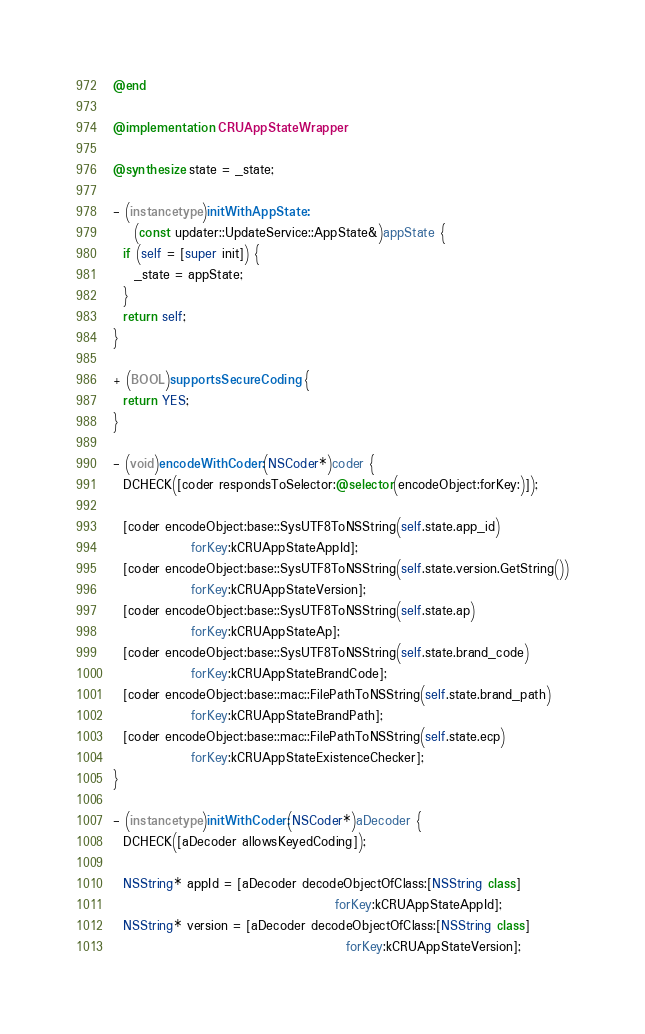<code> <loc_0><loc_0><loc_500><loc_500><_ObjectiveC_>
@end

@implementation CRUAppStateWrapper

@synthesize state = _state;

- (instancetype)initWithAppState:
    (const updater::UpdateService::AppState&)appState {
  if (self = [super init]) {
    _state = appState;
  }
  return self;
}

+ (BOOL)supportsSecureCoding {
  return YES;
}

- (void)encodeWithCoder:(NSCoder*)coder {
  DCHECK([coder respondsToSelector:@selector(encodeObject:forKey:)]);

  [coder encodeObject:base::SysUTF8ToNSString(self.state.app_id)
               forKey:kCRUAppStateAppId];
  [coder encodeObject:base::SysUTF8ToNSString(self.state.version.GetString())
               forKey:kCRUAppStateVersion];
  [coder encodeObject:base::SysUTF8ToNSString(self.state.ap)
               forKey:kCRUAppStateAp];
  [coder encodeObject:base::SysUTF8ToNSString(self.state.brand_code)
               forKey:kCRUAppStateBrandCode];
  [coder encodeObject:base::mac::FilePathToNSString(self.state.brand_path)
               forKey:kCRUAppStateBrandPath];
  [coder encodeObject:base::mac::FilePathToNSString(self.state.ecp)
               forKey:kCRUAppStateExistenceChecker];
}

- (instancetype)initWithCoder:(NSCoder*)aDecoder {
  DCHECK([aDecoder allowsKeyedCoding]);

  NSString* appId = [aDecoder decodeObjectOfClass:[NSString class]
                                           forKey:kCRUAppStateAppId];
  NSString* version = [aDecoder decodeObjectOfClass:[NSString class]
                                             forKey:kCRUAppStateVersion];
</code> 